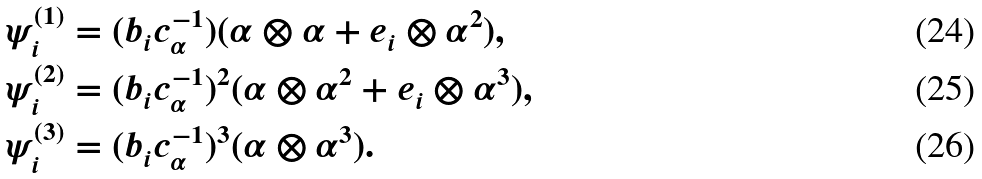<formula> <loc_0><loc_0><loc_500><loc_500>\psi _ { i } ^ { ( 1 ) } & = ( b _ { i } c _ { \alpha } ^ { - 1 } ) ( \alpha \otimes \alpha + e _ { i } \otimes \alpha ^ { 2 } ) , \\ \psi _ { i } ^ { ( 2 ) } & = ( b _ { i } c _ { \alpha } ^ { - 1 } ) ^ { 2 } ( \alpha \otimes \alpha ^ { 2 } + e _ { i } \otimes \alpha ^ { 3 } ) , \\ \psi _ { i } ^ { ( 3 ) } & = ( b _ { i } c _ { \alpha } ^ { - 1 } ) ^ { 3 } ( \alpha \otimes \alpha ^ { 3 } ) .</formula> 